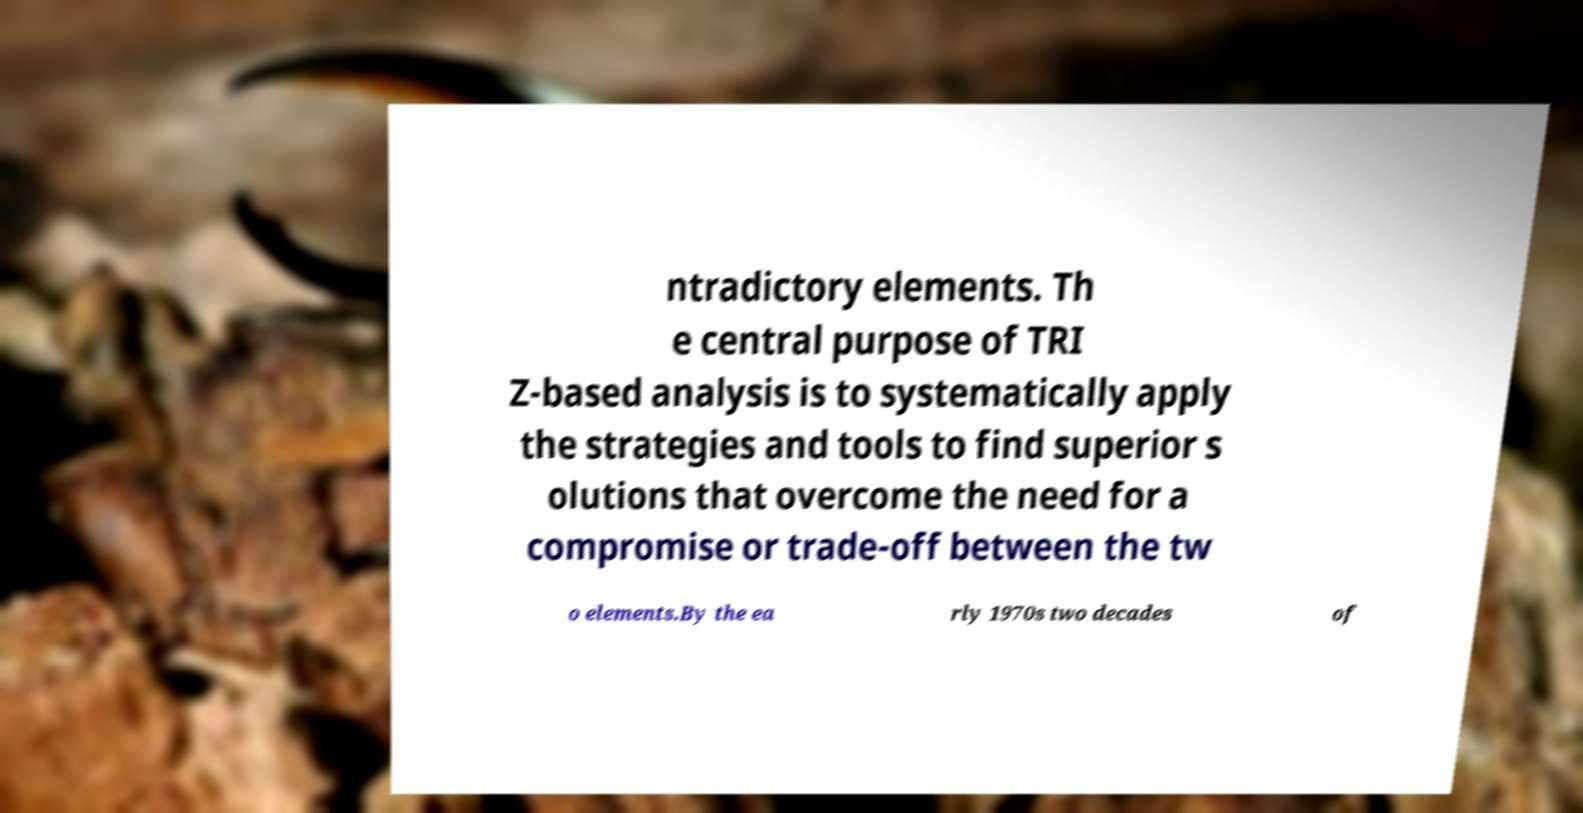Can you read and provide the text displayed in the image?This photo seems to have some interesting text. Can you extract and type it out for me? ntradictory elements. Th e central purpose of TRI Z-based analysis is to systematically apply the strategies and tools to find superior s olutions that overcome the need for a compromise or trade-off between the tw o elements.By the ea rly 1970s two decades of 